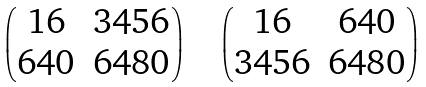<formula> <loc_0><loc_0><loc_500><loc_500>\begin{pmatrix} 1 6 & 3 4 5 6 \\ 6 4 0 & 6 4 8 0 \end{pmatrix} \quad \begin{pmatrix} 1 6 & 6 4 0 \\ 3 4 5 6 & 6 4 8 0 \end{pmatrix}</formula> 